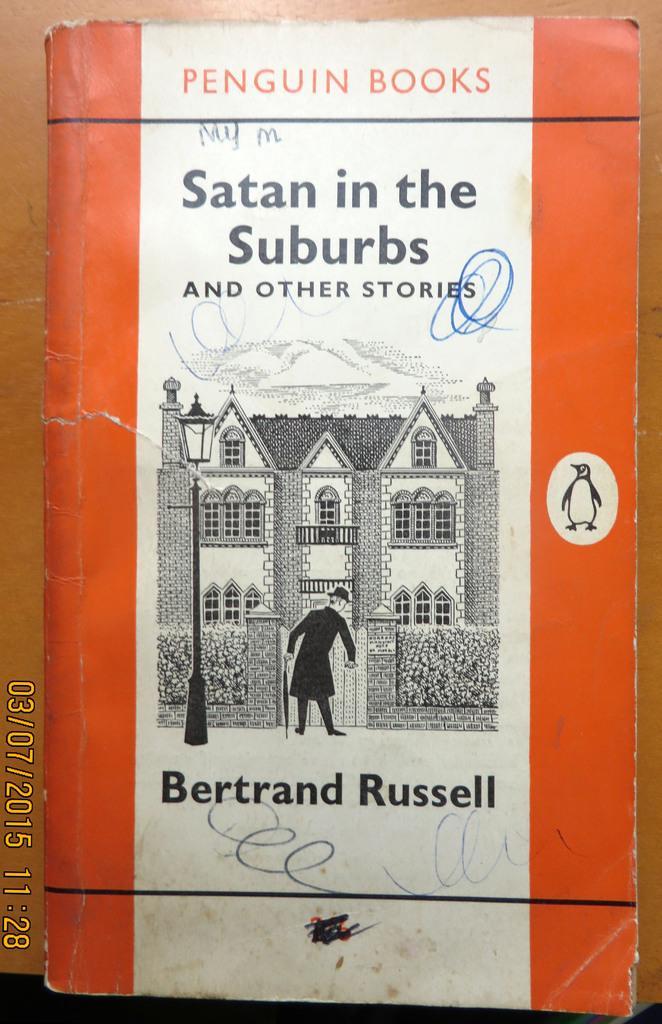Describe this image in one or two sentences. In this image we can see a book placed on the surface and we can also see some text written on it. 